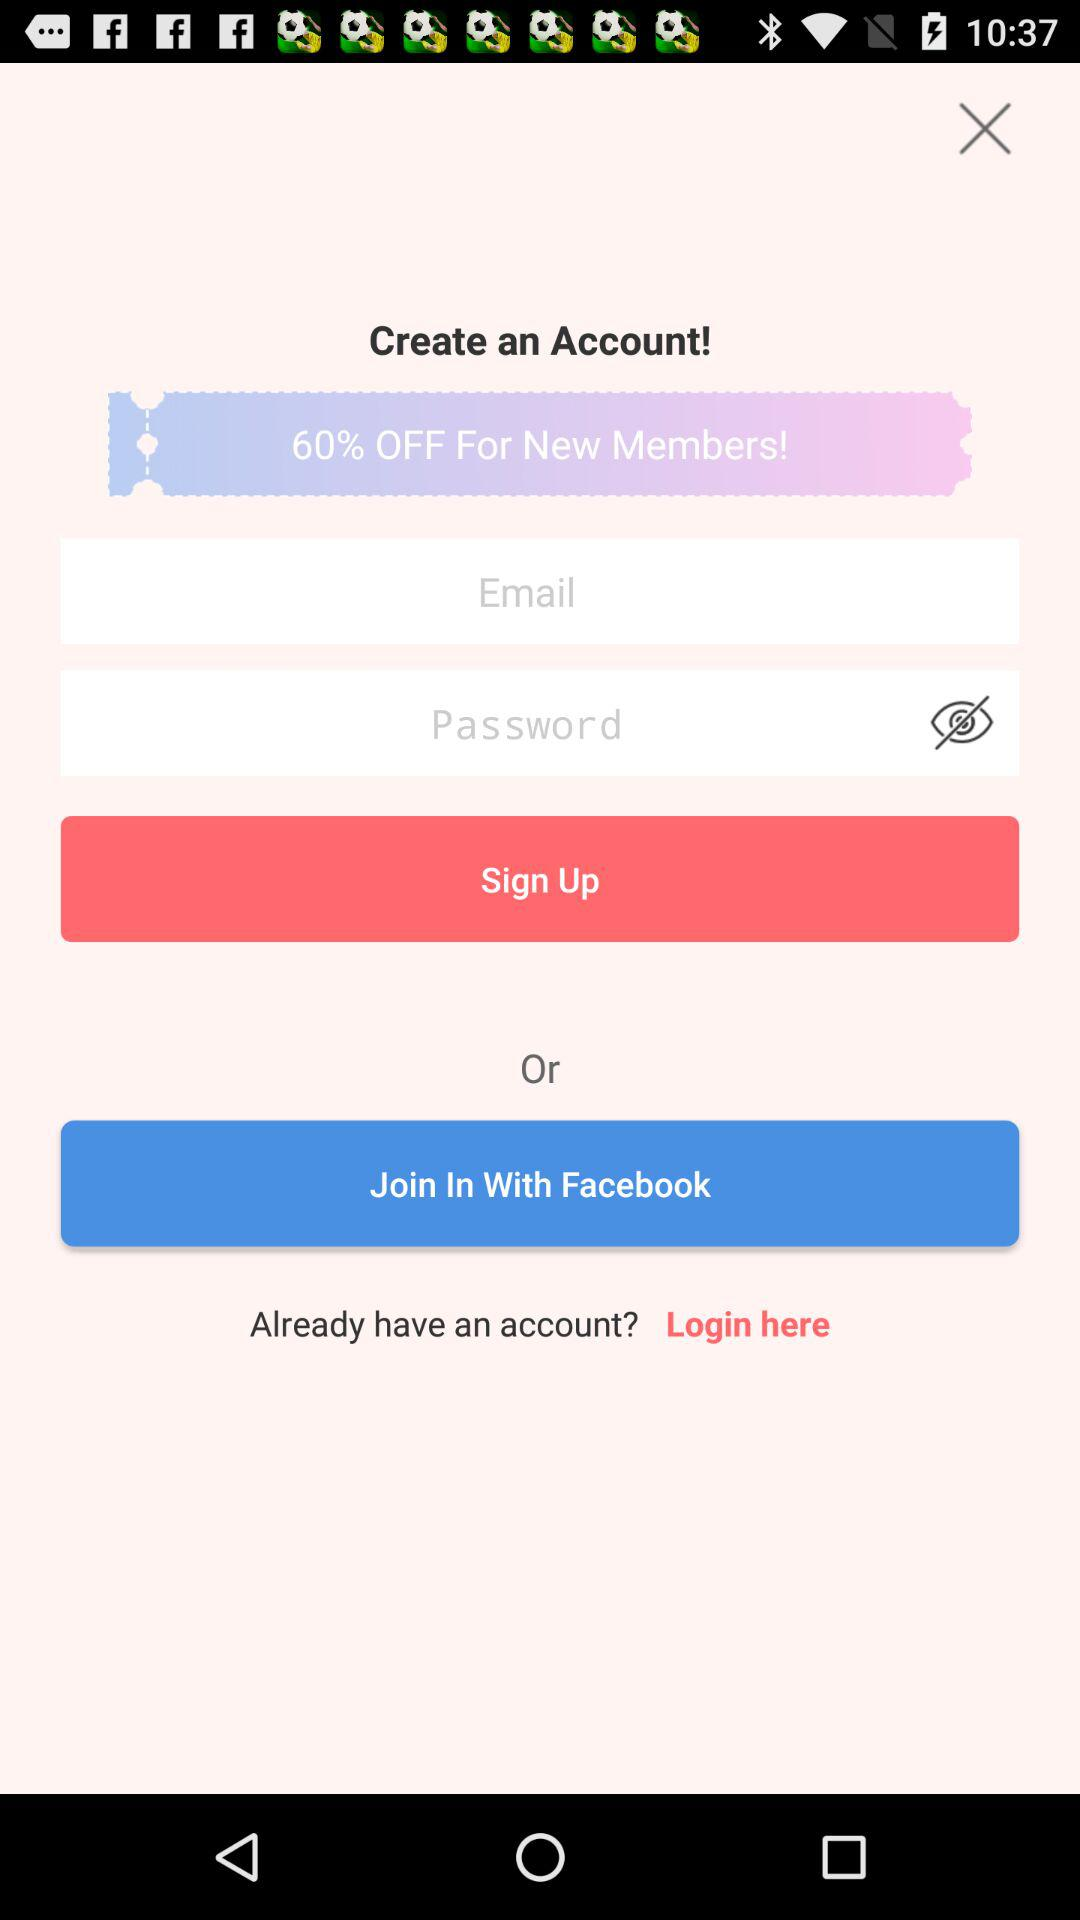What are the different options through which we can log in?
When the provided information is insufficient, respond with <no answer>. <no answer> 